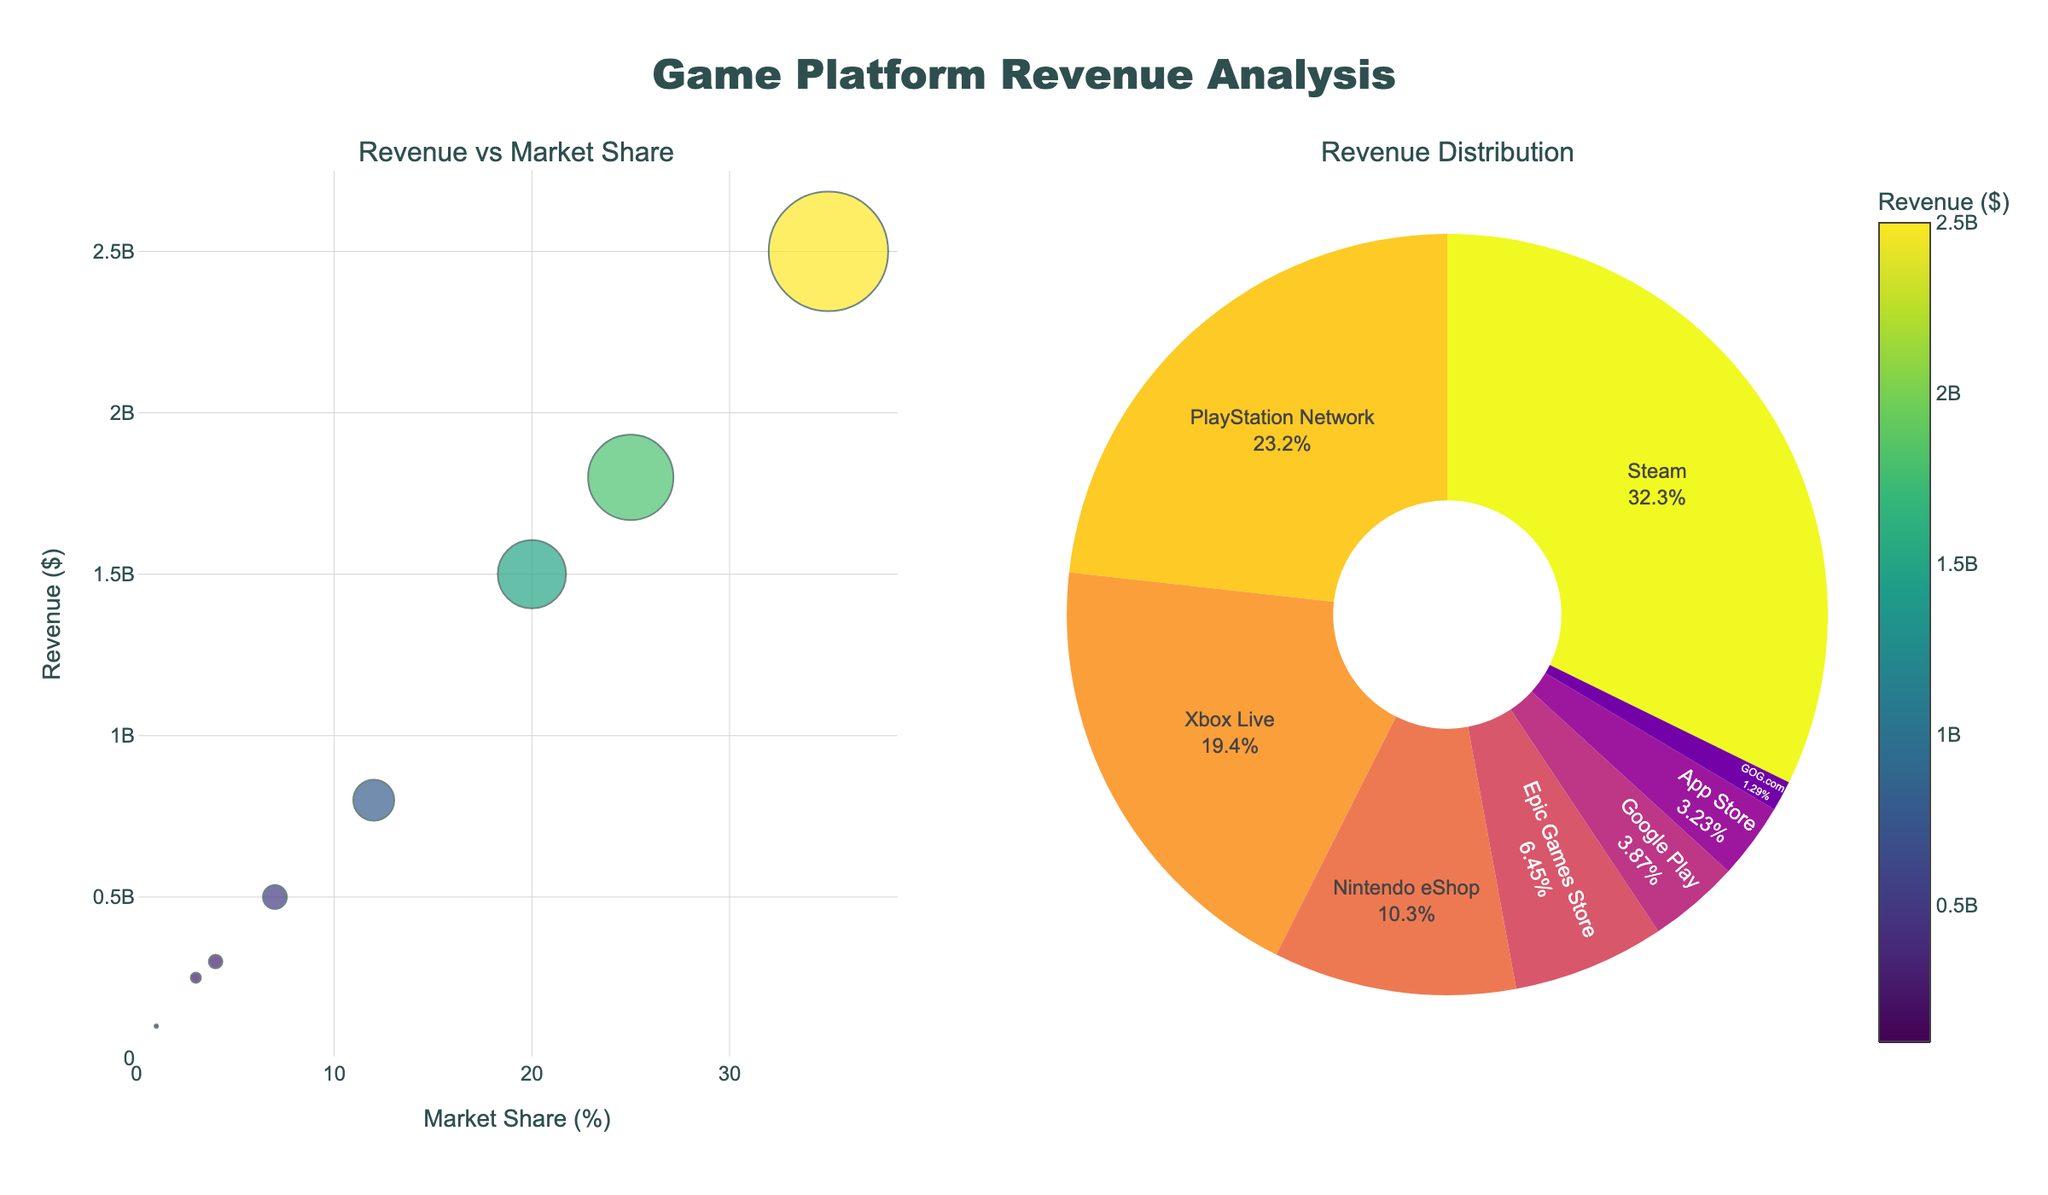Which platform has the highest revenue? To find the platform with the highest revenue, look at the scatter plot or the pie chart which both represent revenue information. The platform with the largest bubble or the largest pie slice corresponds to the highest revenue.
Answer: Steam What is the market share of PlayStation Network? Check the scatter plot where market share is represented on the x-axis and look for the bubble labeled "PlayStation Network." The x-coordinate of this bubble is the market share.
Answer: 25% How does Xbox Live's revenue compare to Nintendo eShop's revenue? Compare the y-coordinates of the bubbles labeled "Xbox Live" and "Nintendo eShop" in the scatter plot. Xbox Live's y-coordinate (revenue) is higher than Nintendo eShop's.
Answer: Higher What is the total combined revenue of Google Play and App Store? Add the revenue values of Google Play and App Store as shown in the chart. Google Play is $300,000,000 and App Store is $250,000,000. The total is $300,000,000 + $250,000,000.
Answer: $550,000,000 Which platform has the smallest market share, and what is its revenue? Look at the scatter plot and find the smallest bubble, which represents the smallest market share. The platform GOG.com has the smallest bubble. Check its corresponding revenue on the y-axis.
Answer: GOG.com, $100,000,000 What percentage of total revenue does Steam contribute? To find the percentage contributed by Steam, locate its revenue ($2,500,000,000) and divide by the total revenue (sum of all revenues). (2,500,000,000 ÷ 7,050,000,000) x 100 = 35.46%
Answer: 35.46% Which two platforms have combined market shares equal to Xbox Live's market share? Find the market share of Xbox Live (20%) and look for two other platforms whose market shares sum to 20%. App Store (3%) and Google Play (4%) combine to 7%, and adding Epic Games Store (7%) gets 14%. Using PlayStation Network (25%) and Nintendo eShop (12%), none perfectly match but in real data scenarios sometimes approximations are needed.
Answer: No exact combination matches What is the average revenue of the platforms with market share above 20%? Identify platforms with market share above 20% (Steam and PlayStation Network). Their revenues are $2,500,000,000 and $1,800,000,000. Find the average: (2,500,000,000 + 1,800,000,000) ÷ 2.
Answer: $2,150,000,000 What is the relationship between revenue and market share across all platforms? Analyze the trend in the scatter plot with market share on the x-axis and revenue on the y-axis. Generally, higher market share correlates to higher revenue, indicating a positive relationship.
Answer: Positive correlation 